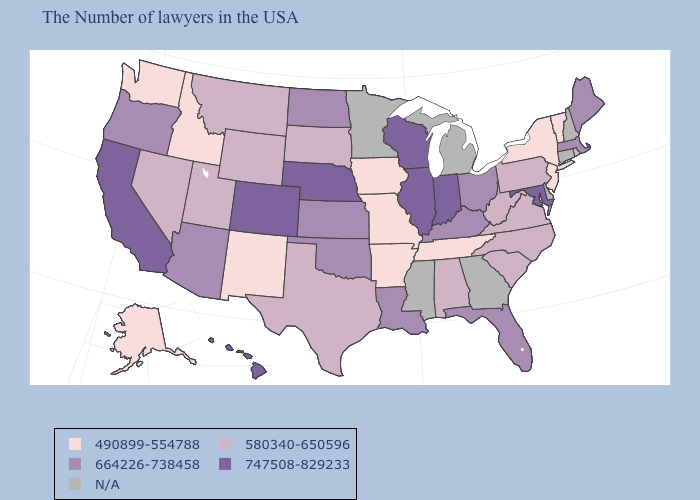Among the states that border Mississippi , which have the highest value?
Quick response, please. Louisiana. What is the value of Arkansas?
Be succinct. 490899-554788. Name the states that have a value in the range 490899-554788?
Give a very brief answer. Vermont, New York, New Jersey, Tennessee, Missouri, Arkansas, Iowa, New Mexico, Idaho, Washington, Alaska. Does Rhode Island have the highest value in the USA?
Answer briefly. No. Name the states that have a value in the range N/A?
Give a very brief answer. New Hampshire, Connecticut, Delaware, Georgia, Michigan, Mississippi, Minnesota. Name the states that have a value in the range N/A?
Short answer required. New Hampshire, Connecticut, Delaware, Georgia, Michigan, Mississippi, Minnesota. Does Oregon have the lowest value in the West?
Quick response, please. No. What is the value of Washington?
Write a very short answer. 490899-554788. Among the states that border Utah , does Nevada have the highest value?
Be succinct. No. Name the states that have a value in the range N/A?
Concise answer only. New Hampshire, Connecticut, Delaware, Georgia, Michigan, Mississippi, Minnesota. Does the first symbol in the legend represent the smallest category?
Be succinct. Yes. Name the states that have a value in the range 747508-829233?
Give a very brief answer. Maryland, Indiana, Wisconsin, Illinois, Nebraska, Colorado, California, Hawaii. What is the value of Minnesota?
Write a very short answer. N/A. 